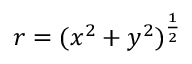Convert formula to latex. <formula><loc_0><loc_0><loc_500><loc_500>r = ( x ^ { 2 } + y ^ { 2 } ) ^ { \frac { 1 } { 2 } }</formula> 